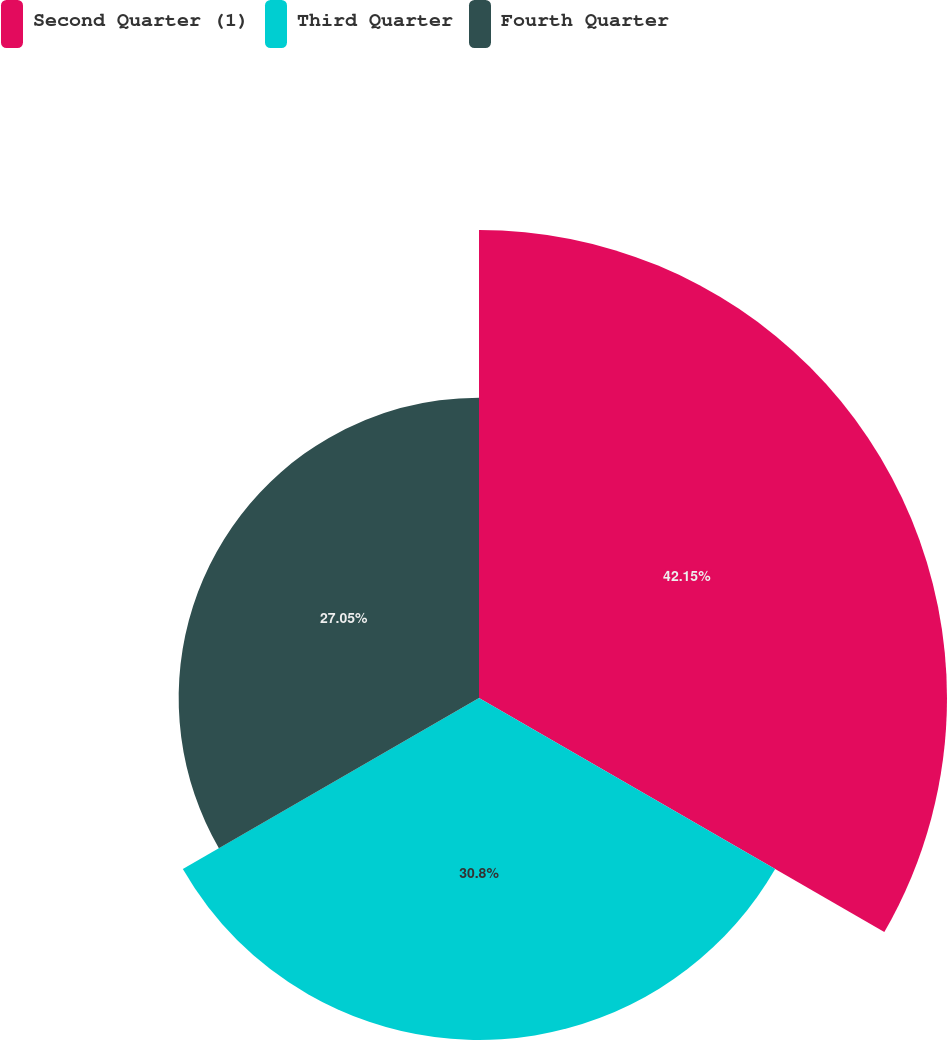Convert chart. <chart><loc_0><loc_0><loc_500><loc_500><pie_chart><fcel>Second Quarter (1)<fcel>Third Quarter<fcel>Fourth Quarter<nl><fcel>42.15%<fcel>30.8%<fcel>27.05%<nl></chart> 